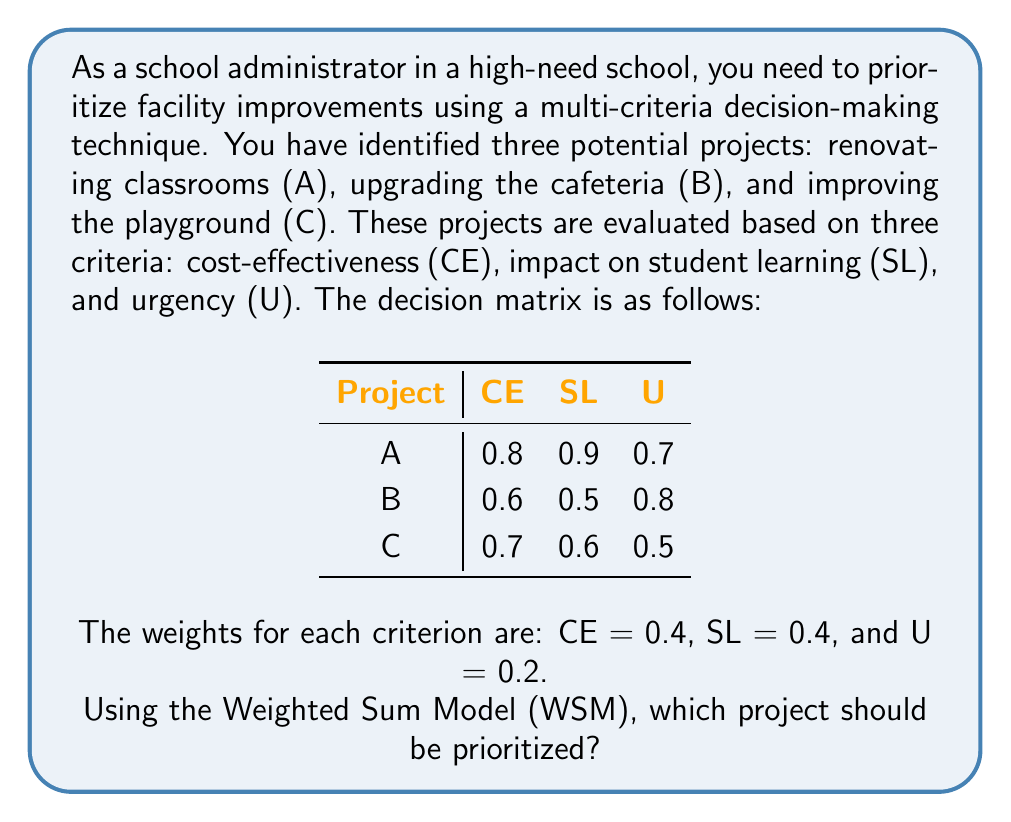Provide a solution to this math problem. To solve this problem using the Weighted Sum Model (WSM), we need to follow these steps:

1. Multiply each score in the decision matrix by its corresponding criterion weight.
2. Sum the weighted scores for each project.
3. Choose the project with the highest total score.

Let's calculate for each project:

Project A:
$$(0.8 \times 0.4) + (0.9 \times 0.4) + (0.7 \times 0.2) = 0.32 + 0.36 + 0.14 = 0.82$$

Project B:
$$(0.6 \times 0.4) + (0.5 \times 0.4) + (0.8 \times 0.2) = 0.24 + 0.20 + 0.16 = 0.60$$

Project C:
$$(0.7 \times 0.4) + (0.6 \times 0.4) + (0.5 \times 0.2) = 0.28 + 0.24 + 0.10 = 0.62$$

Comparing the total scores:
Project A: 0.82
Project B: 0.60
Project C: 0.62

Project A has the highest score, so it should be prioritized.
Answer: Project A (renovating classrooms) 